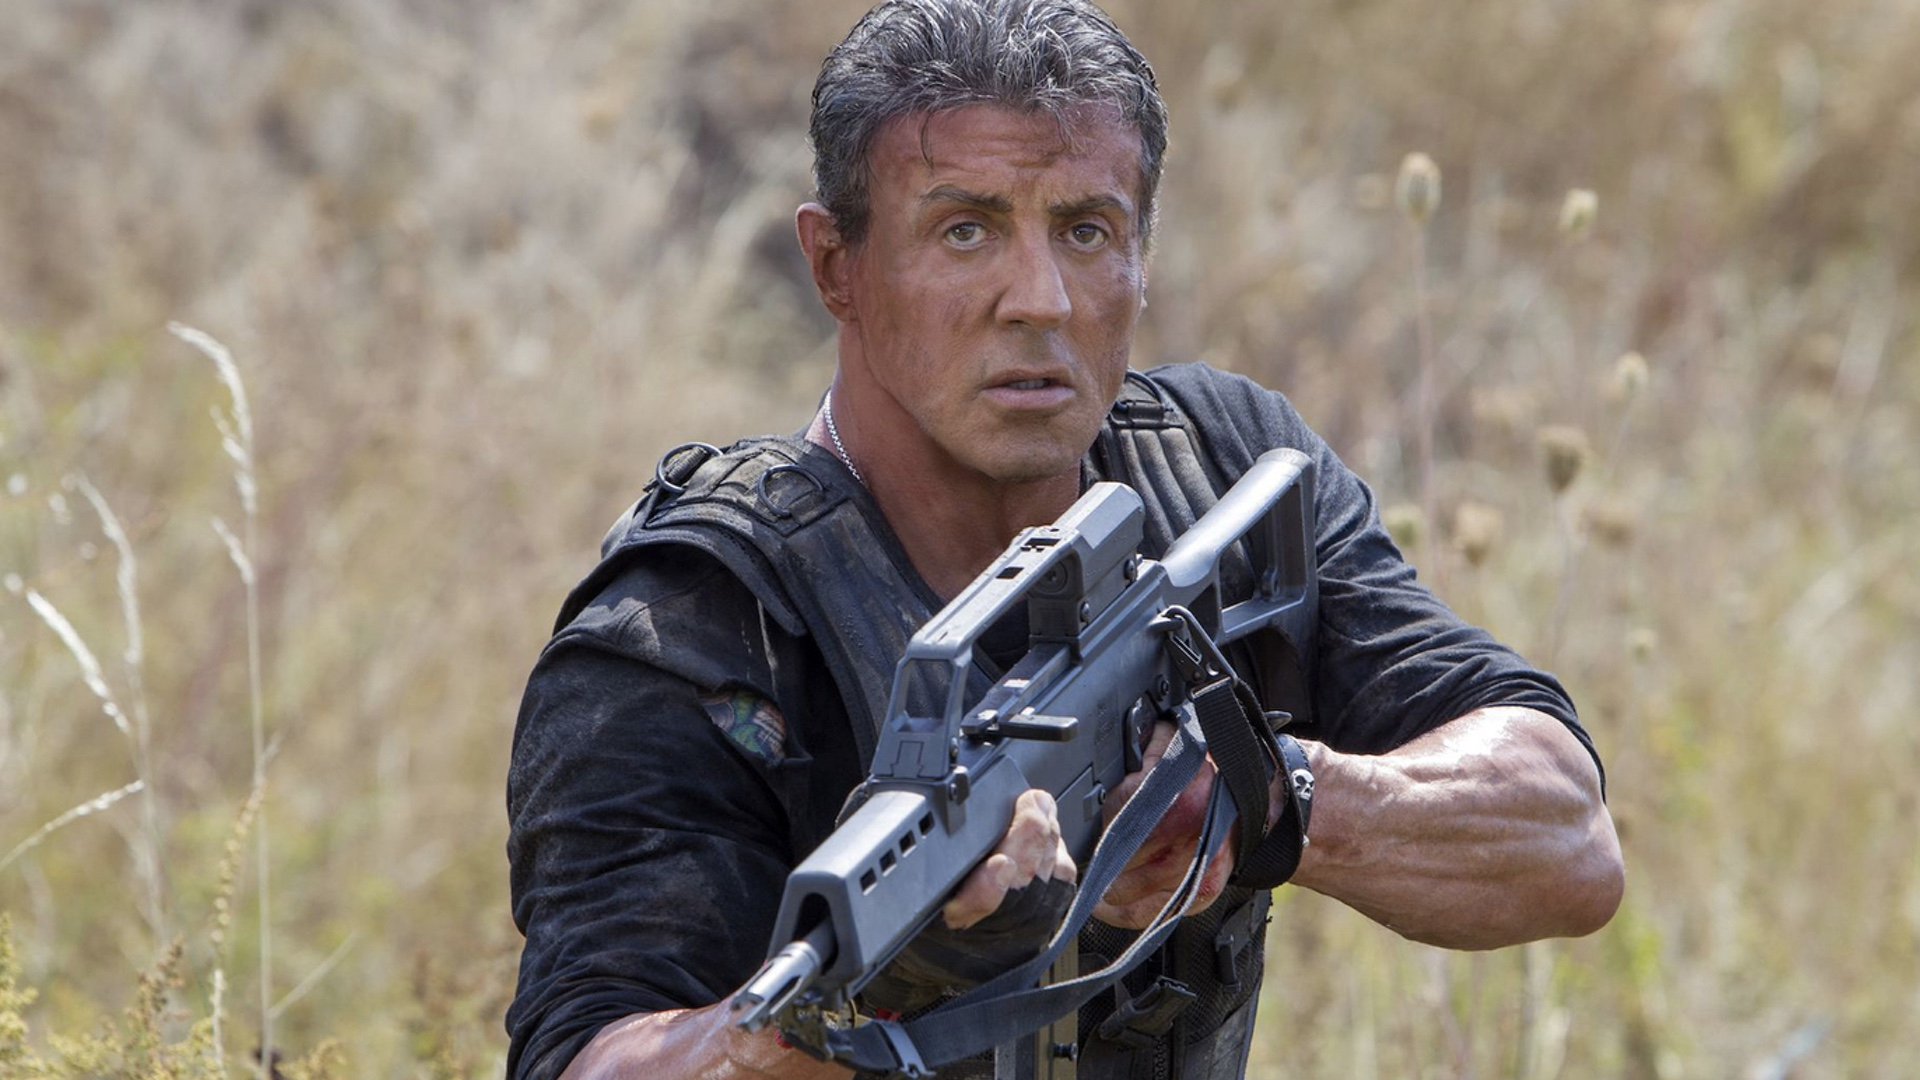Can you describe the setting and mood of this image? The setting of the image is a field teeming with tall grasses and wildflowers. This natural and serene background sets an interesting contrast to the central figure, who is gripping a large firearm and dressed in a black combat vest, creating a sense of tension and readiness. The mood is intense and serious, reflecting the character's preparedness for any sudden confrontation. 